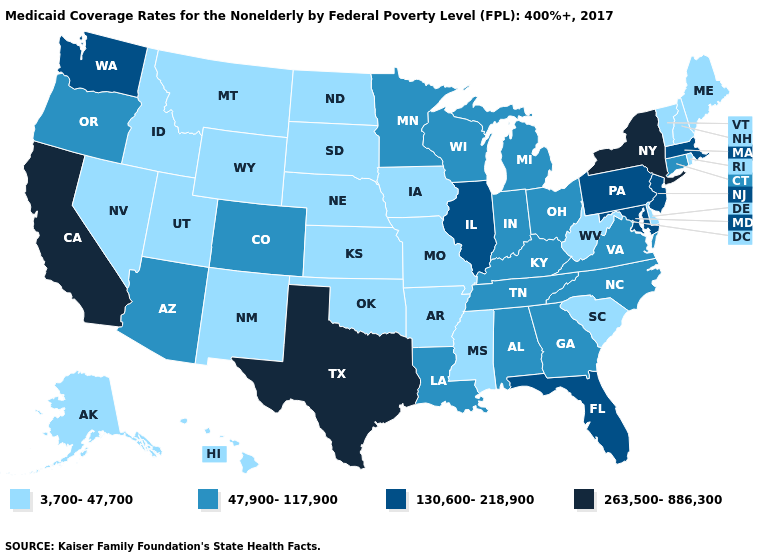Does California have the highest value in the West?
Short answer required. Yes. Name the states that have a value in the range 3,700-47,700?
Give a very brief answer. Alaska, Arkansas, Delaware, Hawaii, Idaho, Iowa, Kansas, Maine, Mississippi, Missouri, Montana, Nebraska, Nevada, New Hampshire, New Mexico, North Dakota, Oklahoma, Rhode Island, South Carolina, South Dakota, Utah, Vermont, West Virginia, Wyoming. What is the lowest value in states that border Delaware?
Write a very short answer. 130,600-218,900. What is the value of New Jersey?
Keep it brief. 130,600-218,900. Name the states that have a value in the range 263,500-886,300?
Keep it brief. California, New York, Texas. What is the value of Louisiana?
Give a very brief answer. 47,900-117,900. Which states have the highest value in the USA?
Quick response, please. California, New York, Texas. What is the value of New Mexico?
Be succinct. 3,700-47,700. Among the states that border Pennsylvania , which have the lowest value?
Be succinct. Delaware, West Virginia. Name the states that have a value in the range 263,500-886,300?
Concise answer only. California, New York, Texas. What is the value of Iowa?
Short answer required. 3,700-47,700. Among the states that border Kansas , does Oklahoma have the highest value?
Quick response, please. No. Does the first symbol in the legend represent the smallest category?
Answer briefly. Yes. What is the highest value in the South ?
Write a very short answer. 263,500-886,300. 